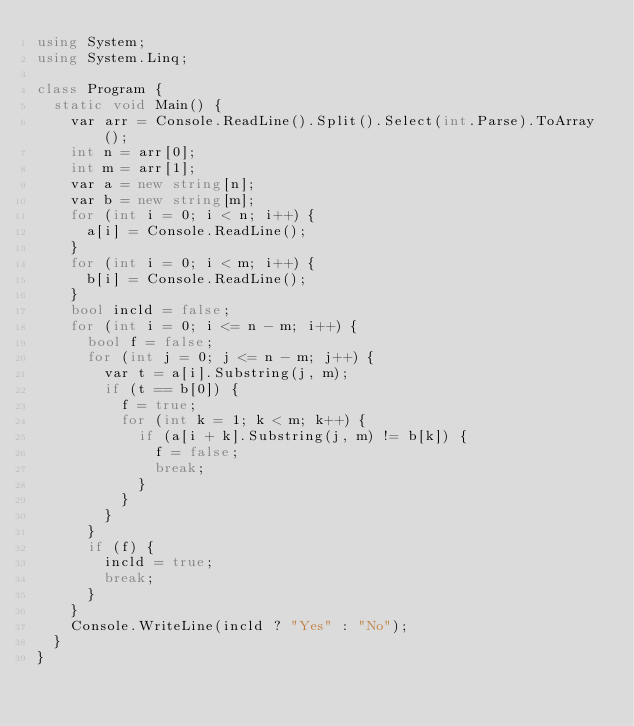<code> <loc_0><loc_0><loc_500><loc_500><_C#_>using System;
using System.Linq;

class Program {
  static void Main() {
    var arr = Console.ReadLine().Split().Select(int.Parse).ToArray();
    int n = arr[0];
    int m = arr[1];
    var a = new string[n];
    var b = new string[m];
    for (int i = 0; i < n; i++) {
      a[i] = Console.ReadLine();
    }
    for (int i = 0; i < m; i++) {
      b[i] = Console.ReadLine();
    }
    bool incld = false;
    for (int i = 0; i <= n - m; i++) {
      bool f = false;
      for (int j = 0; j <= n - m; j++) {
        var t = a[i].Substring(j, m);
        if (t == b[0]) {
          f = true;
          for (int k = 1; k < m; k++) {
            if (a[i + k].Substring(j, m) != b[k]) {
              f = false;
              break;
            }
          }
        }
      }
      if (f) {
        incld = true;
        break;
      }
    }
    Console.WriteLine(incld ? "Yes" : "No");
  }
}</code> 